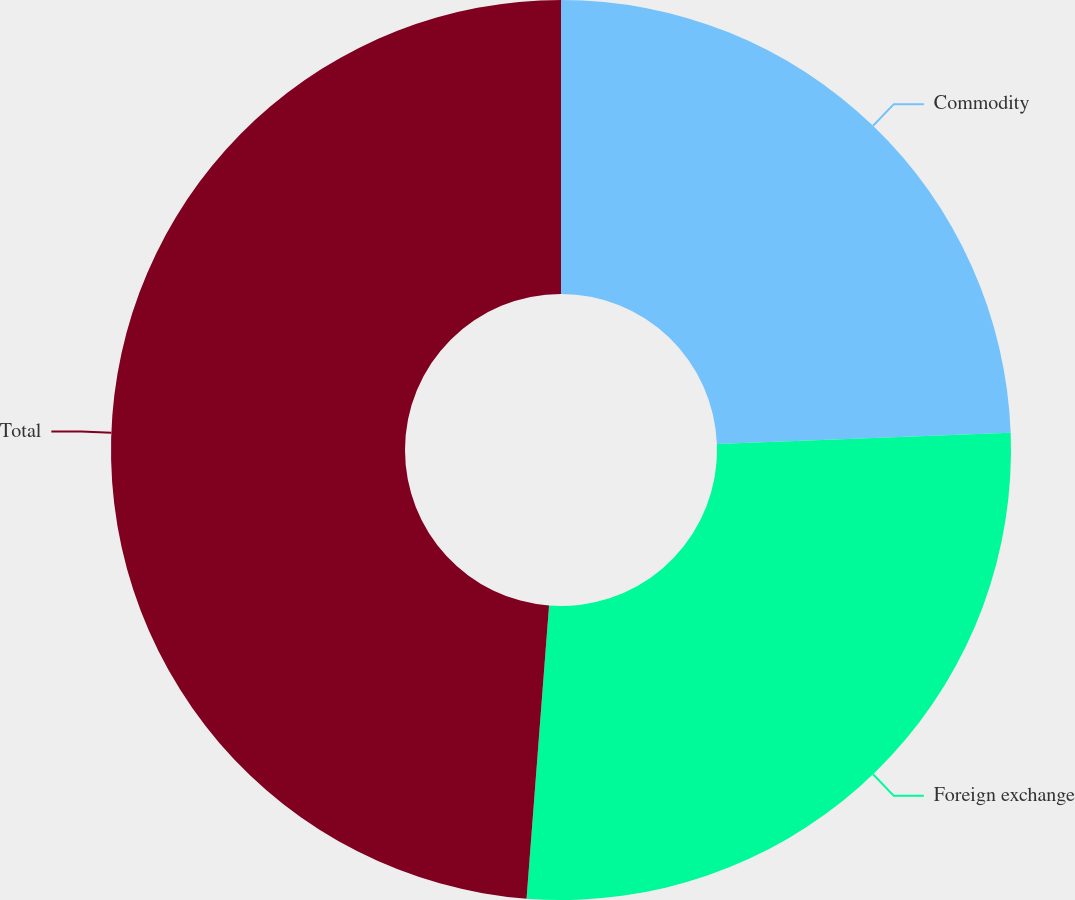Convert chart to OTSL. <chart><loc_0><loc_0><loc_500><loc_500><pie_chart><fcel>Commodity<fcel>Foreign exchange<fcel>Total<nl><fcel>24.39%<fcel>26.83%<fcel>48.78%<nl></chart> 